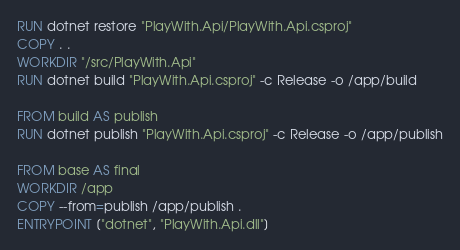Convert code to text. <code><loc_0><loc_0><loc_500><loc_500><_Dockerfile_>RUN dotnet restore "PlayWith.Api/PlayWith.Api.csproj"
COPY . .
WORKDIR "/src/PlayWith.Api"
RUN dotnet build "PlayWith.Api.csproj" -c Release -o /app/build

FROM build AS publish
RUN dotnet publish "PlayWith.Api.csproj" -c Release -o /app/publish

FROM base AS final
WORKDIR /app
COPY --from=publish /app/publish .
ENTRYPOINT ["dotnet", "PlayWith.Api.dll"]
</code> 